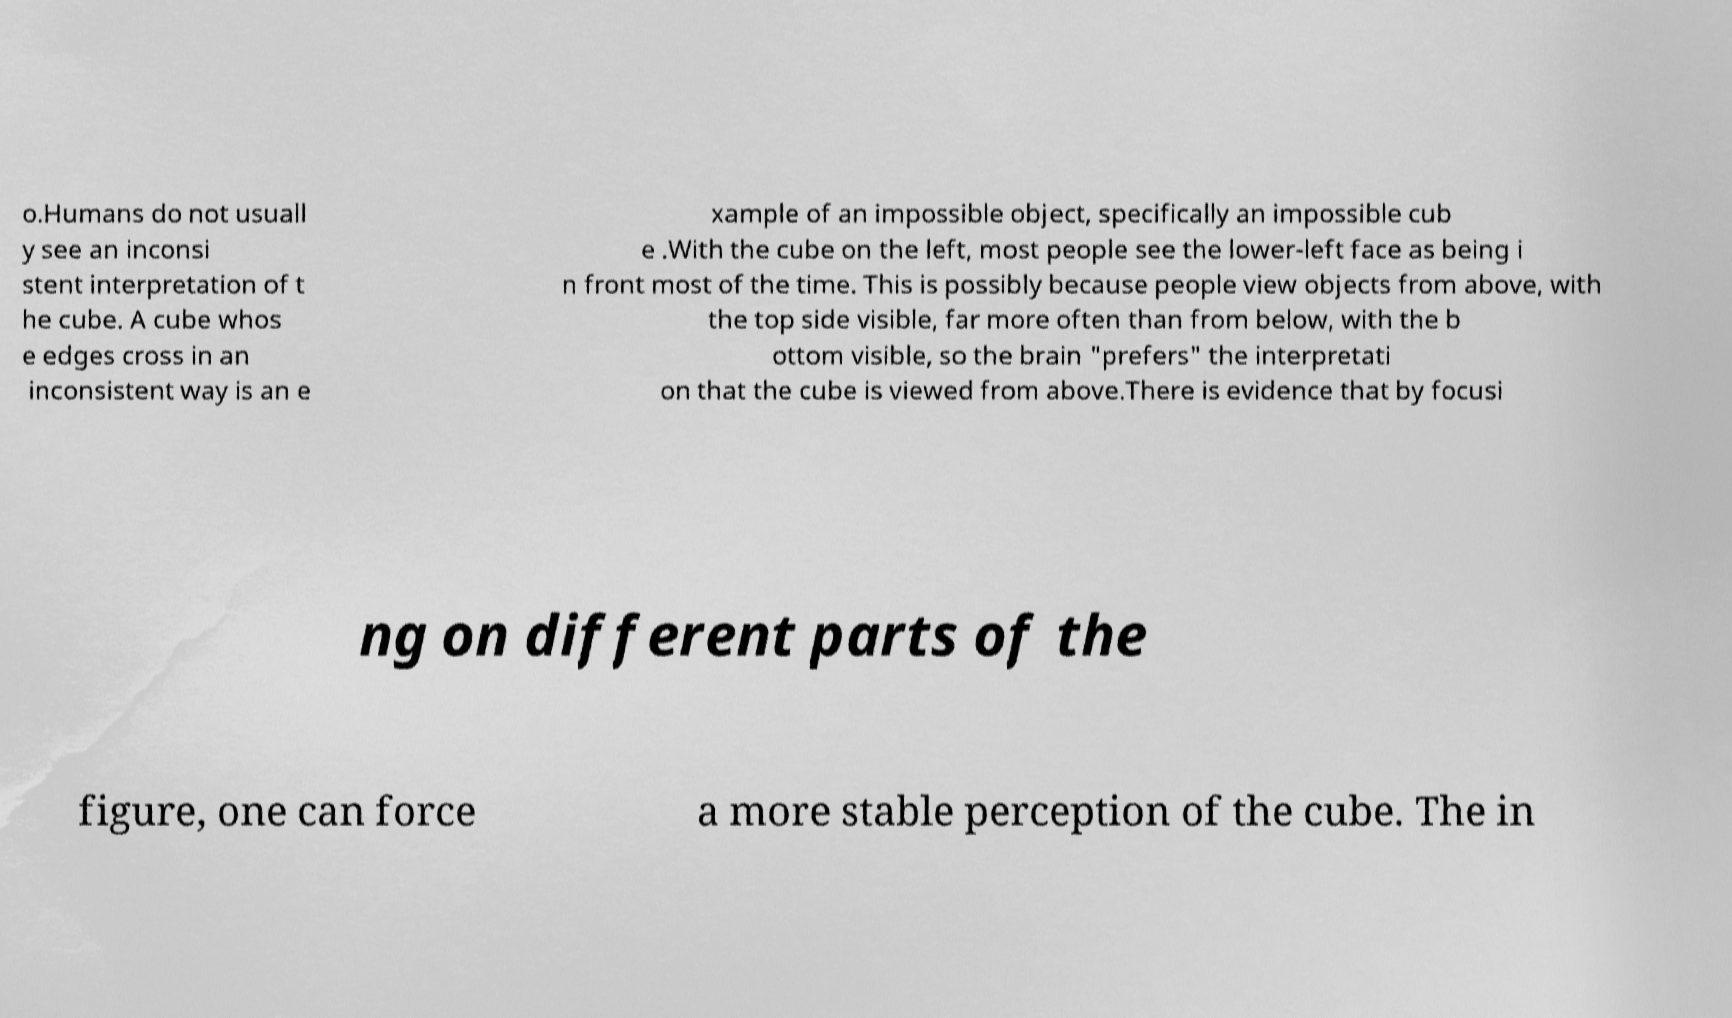Please read and relay the text visible in this image. What does it say? o.Humans do not usuall y see an inconsi stent interpretation of t he cube. A cube whos e edges cross in an inconsistent way is an e xample of an impossible object, specifically an impossible cub e .With the cube on the left, most people see the lower-left face as being i n front most of the time. This is possibly because people view objects from above, with the top side visible, far more often than from below, with the b ottom visible, so the brain "prefers" the interpretati on that the cube is viewed from above.There is evidence that by focusi ng on different parts of the figure, one can force a more stable perception of the cube. The in 